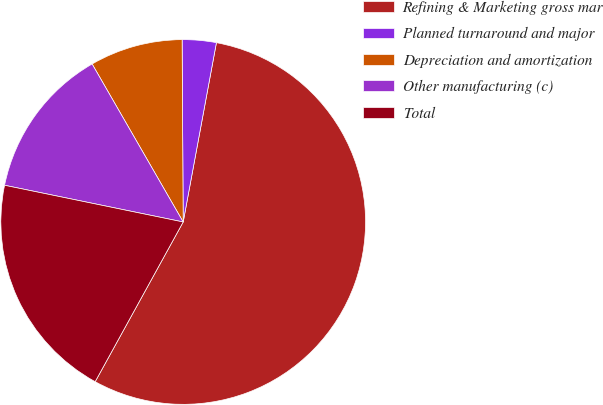Convert chart to OTSL. <chart><loc_0><loc_0><loc_500><loc_500><pie_chart><fcel>Refining & Marketing gross mar<fcel>Planned turnaround and major<fcel>Depreciation and amortization<fcel>Other manufacturing (c)<fcel>Total<nl><fcel>55.1%<fcel>3.01%<fcel>8.23%<fcel>13.45%<fcel>20.21%<nl></chart> 